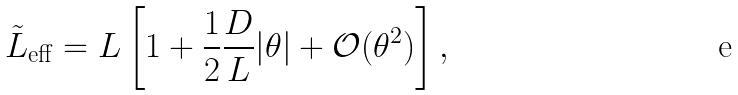<formula> <loc_0><loc_0><loc_500><loc_500>\tilde { L } _ { \text {eff} } = L \left [ 1 + \frac { 1 } { 2 } \frac { D } { L } | \theta | + \mathcal { O } ( \theta ^ { 2 } ) \right ] ,</formula> 